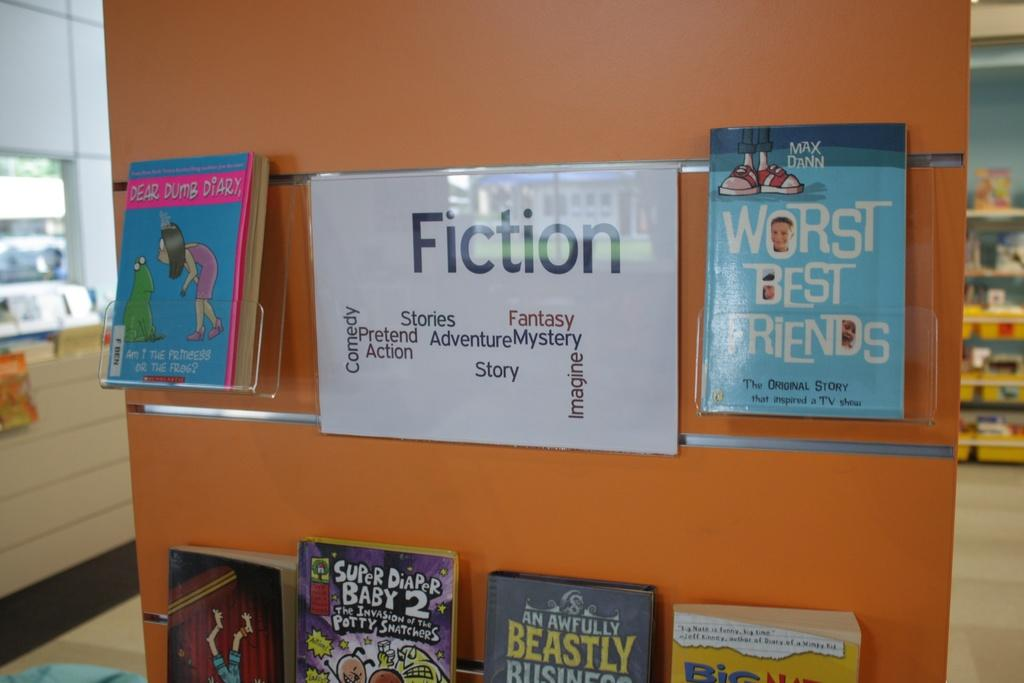<image>
Summarize the visual content of the image. A section of Fiction books are on an endcap in a library. 